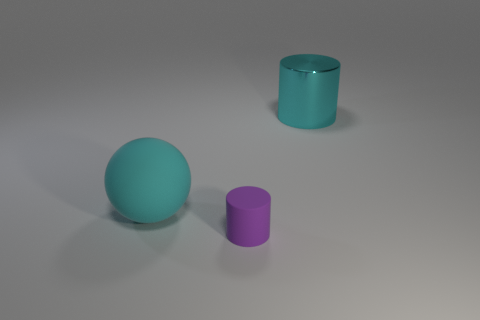Are there any big cyan spheres behind the large cyan ball?
Your response must be concise. No. Do the large rubber object and the tiny rubber object have the same color?
Keep it short and to the point. No. What number of shiny objects are the same color as the rubber ball?
Your response must be concise. 1. What is the size of the cyan object behind the big object that is on the left side of the small matte thing?
Give a very brief answer. Large. There is a tiny purple matte thing; what shape is it?
Provide a succinct answer. Cylinder. What is the cylinder that is to the right of the purple rubber cylinder made of?
Offer a terse response. Metal. What is the color of the object behind the sphere that is in front of the shiny cylinder to the right of the purple matte cylinder?
Keep it short and to the point. Cyan. There is a rubber object that is the same size as the cyan metallic thing; what is its color?
Provide a short and direct response. Cyan. How many matte things are either tiny objects or balls?
Your response must be concise. 2. There is a thing that is made of the same material as the sphere; what color is it?
Provide a succinct answer. Purple. 